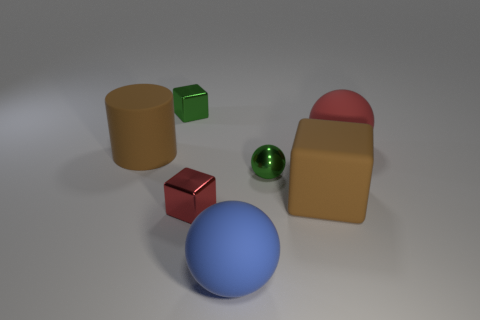What shape is the big rubber object that is the same color as the big matte cube?
Make the answer very short. Cylinder. How many other yellow cylinders are made of the same material as the big cylinder?
Give a very brief answer. 0. What color is the large matte block?
Provide a succinct answer. Brown. What is the color of the metal sphere that is the same size as the green metallic block?
Your answer should be compact. Green. Are there any shiny cubes of the same color as the rubber cylinder?
Your response must be concise. No. There is a brown rubber object right of the green metallic sphere; is its shape the same as the metal object behind the large red sphere?
Give a very brief answer. Yes. What size is the matte cube that is the same color as the cylinder?
Offer a terse response. Large. What number of other objects are there of the same size as the blue matte thing?
Give a very brief answer. 3. Is the color of the big matte cube the same as the small metallic block behind the small sphere?
Provide a succinct answer. No. Are there fewer small green metal balls that are in front of the green sphere than shiny things on the left side of the blue rubber sphere?
Your answer should be compact. Yes. 